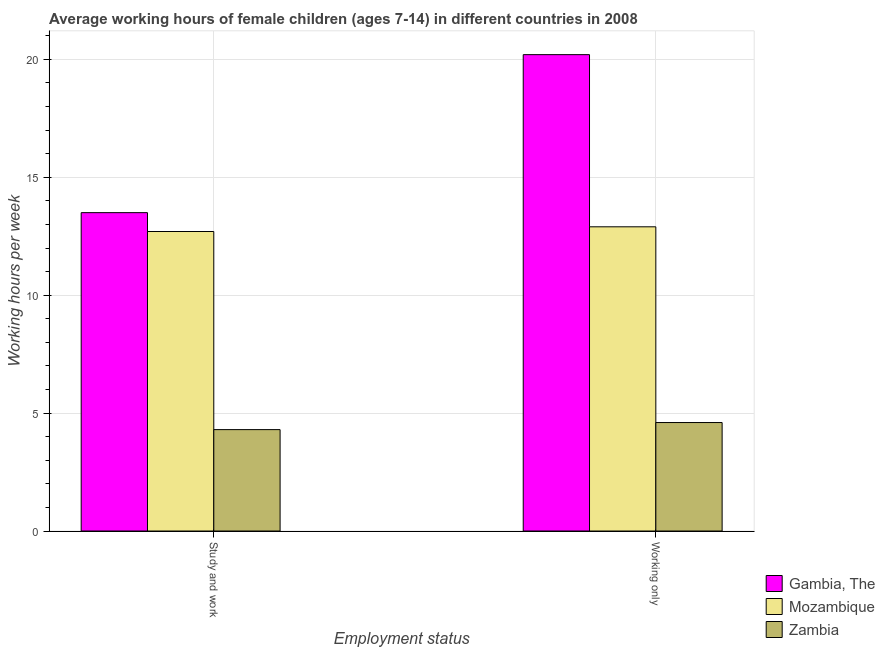Are the number of bars per tick equal to the number of legend labels?
Keep it short and to the point. Yes. Are the number of bars on each tick of the X-axis equal?
Make the answer very short. Yes. How many bars are there on the 2nd tick from the left?
Ensure brevity in your answer.  3. What is the label of the 1st group of bars from the left?
Offer a terse response. Study and work. What is the average working hour of children involved in only work in Gambia, The?
Give a very brief answer. 20.2. Across all countries, what is the maximum average working hour of children involved in only work?
Give a very brief answer. 20.2. Across all countries, what is the minimum average working hour of children involved in study and work?
Make the answer very short. 4.3. In which country was the average working hour of children involved in only work maximum?
Ensure brevity in your answer.  Gambia, The. In which country was the average working hour of children involved in only work minimum?
Your response must be concise. Zambia. What is the total average working hour of children involved in study and work in the graph?
Your answer should be compact. 30.5. What is the difference between the average working hour of children involved in study and work in Mozambique and that in Gambia, The?
Your answer should be compact. -0.8. What is the average average working hour of children involved in only work per country?
Offer a terse response. 12.57. What is the difference between the average working hour of children involved in only work and average working hour of children involved in study and work in Mozambique?
Ensure brevity in your answer.  0.2. In how many countries, is the average working hour of children involved in study and work greater than 16 hours?
Your answer should be very brief. 0. What is the ratio of the average working hour of children involved in study and work in Gambia, The to that in Zambia?
Provide a short and direct response. 3.14. What does the 3rd bar from the left in Study and work represents?
Provide a short and direct response. Zambia. What does the 3rd bar from the right in Study and work represents?
Keep it short and to the point. Gambia, The. Are all the bars in the graph horizontal?
Give a very brief answer. No. Does the graph contain grids?
Keep it short and to the point. Yes. What is the title of the graph?
Make the answer very short. Average working hours of female children (ages 7-14) in different countries in 2008. What is the label or title of the X-axis?
Offer a terse response. Employment status. What is the label or title of the Y-axis?
Provide a short and direct response. Working hours per week. What is the Working hours per week in Zambia in Study and work?
Your answer should be very brief. 4.3. What is the Working hours per week of Gambia, The in Working only?
Your response must be concise. 20.2. What is the Working hours per week of Mozambique in Working only?
Offer a terse response. 12.9. Across all Employment status, what is the maximum Working hours per week in Gambia, The?
Provide a short and direct response. 20.2. Across all Employment status, what is the minimum Working hours per week in Gambia, The?
Your response must be concise. 13.5. What is the total Working hours per week of Gambia, The in the graph?
Your answer should be very brief. 33.7. What is the total Working hours per week of Mozambique in the graph?
Provide a succinct answer. 25.6. What is the total Working hours per week in Zambia in the graph?
Your response must be concise. 8.9. What is the difference between the Working hours per week of Mozambique in Study and work and that in Working only?
Make the answer very short. -0.2. What is the average Working hours per week of Gambia, The per Employment status?
Your answer should be compact. 16.85. What is the average Working hours per week of Mozambique per Employment status?
Ensure brevity in your answer.  12.8. What is the average Working hours per week of Zambia per Employment status?
Make the answer very short. 4.45. What is the difference between the Working hours per week in Gambia, The and Working hours per week in Zambia in Study and work?
Your response must be concise. 9.2. What is the difference between the Working hours per week of Mozambique and Working hours per week of Zambia in Working only?
Ensure brevity in your answer.  8.3. What is the ratio of the Working hours per week of Gambia, The in Study and work to that in Working only?
Keep it short and to the point. 0.67. What is the ratio of the Working hours per week in Mozambique in Study and work to that in Working only?
Provide a succinct answer. 0.98. What is the ratio of the Working hours per week in Zambia in Study and work to that in Working only?
Ensure brevity in your answer.  0.93. What is the difference between the highest and the lowest Working hours per week in Gambia, The?
Provide a short and direct response. 6.7. What is the difference between the highest and the lowest Working hours per week of Mozambique?
Your answer should be compact. 0.2. What is the difference between the highest and the lowest Working hours per week in Zambia?
Offer a terse response. 0.3. 